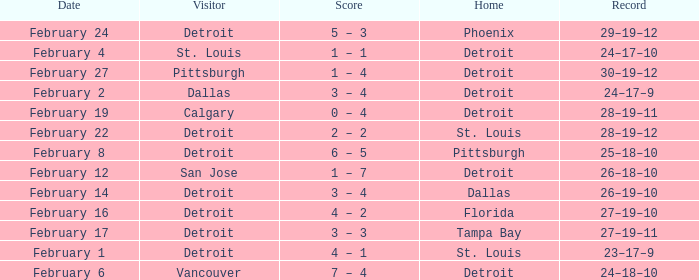What was their record when they were at Pittsburgh? 25–18–10. 